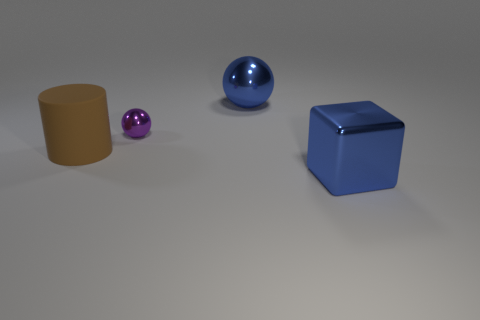Add 3 tiny cyan metal cubes. How many objects exist? 7 Subtract all cubes. How many objects are left? 3 Add 2 large cubes. How many large cubes are left? 3 Add 1 big cylinders. How many big cylinders exist? 2 Subtract 0 red cylinders. How many objects are left? 4 Subtract all purple balls. Subtract all yellow spheres. How many objects are left? 3 